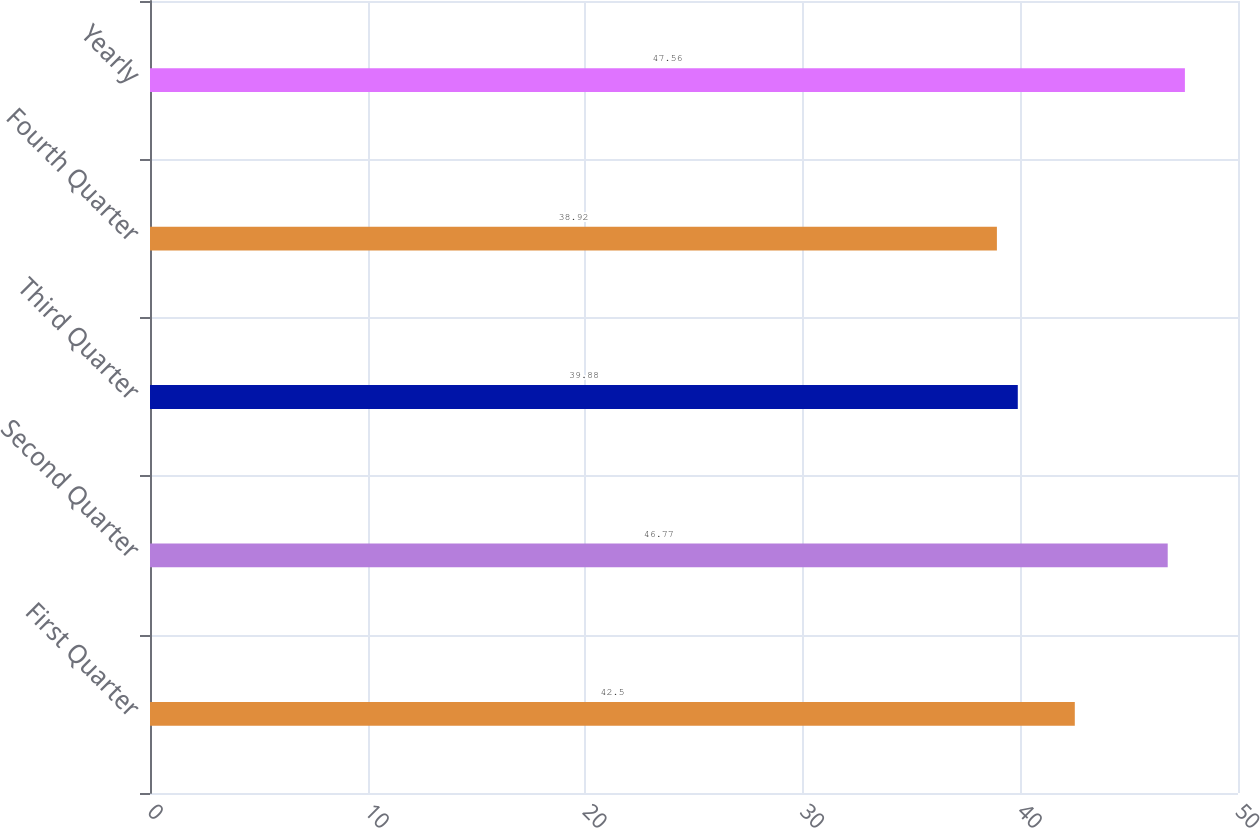<chart> <loc_0><loc_0><loc_500><loc_500><bar_chart><fcel>First Quarter<fcel>Second Quarter<fcel>Third Quarter<fcel>Fourth Quarter<fcel>Yearly<nl><fcel>42.5<fcel>46.77<fcel>39.88<fcel>38.92<fcel>47.56<nl></chart> 